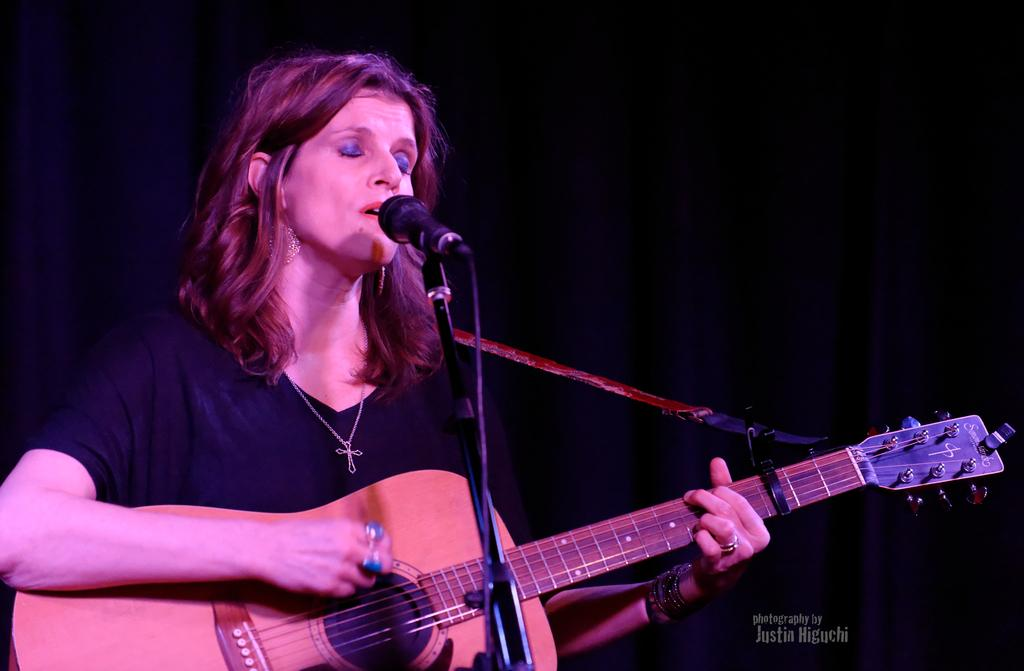Who is the main subject in the image? There is a woman in the image. What is the woman holding in her hand? The woman is holding a guitar in her hand. What type of jewel can be seen on the woman's neck in the image? There is no jewel visible on the woman's neck in the image. Can you describe the waves in the background of the image? There are no waves present in the image; it only features a woman holding a guitar. 